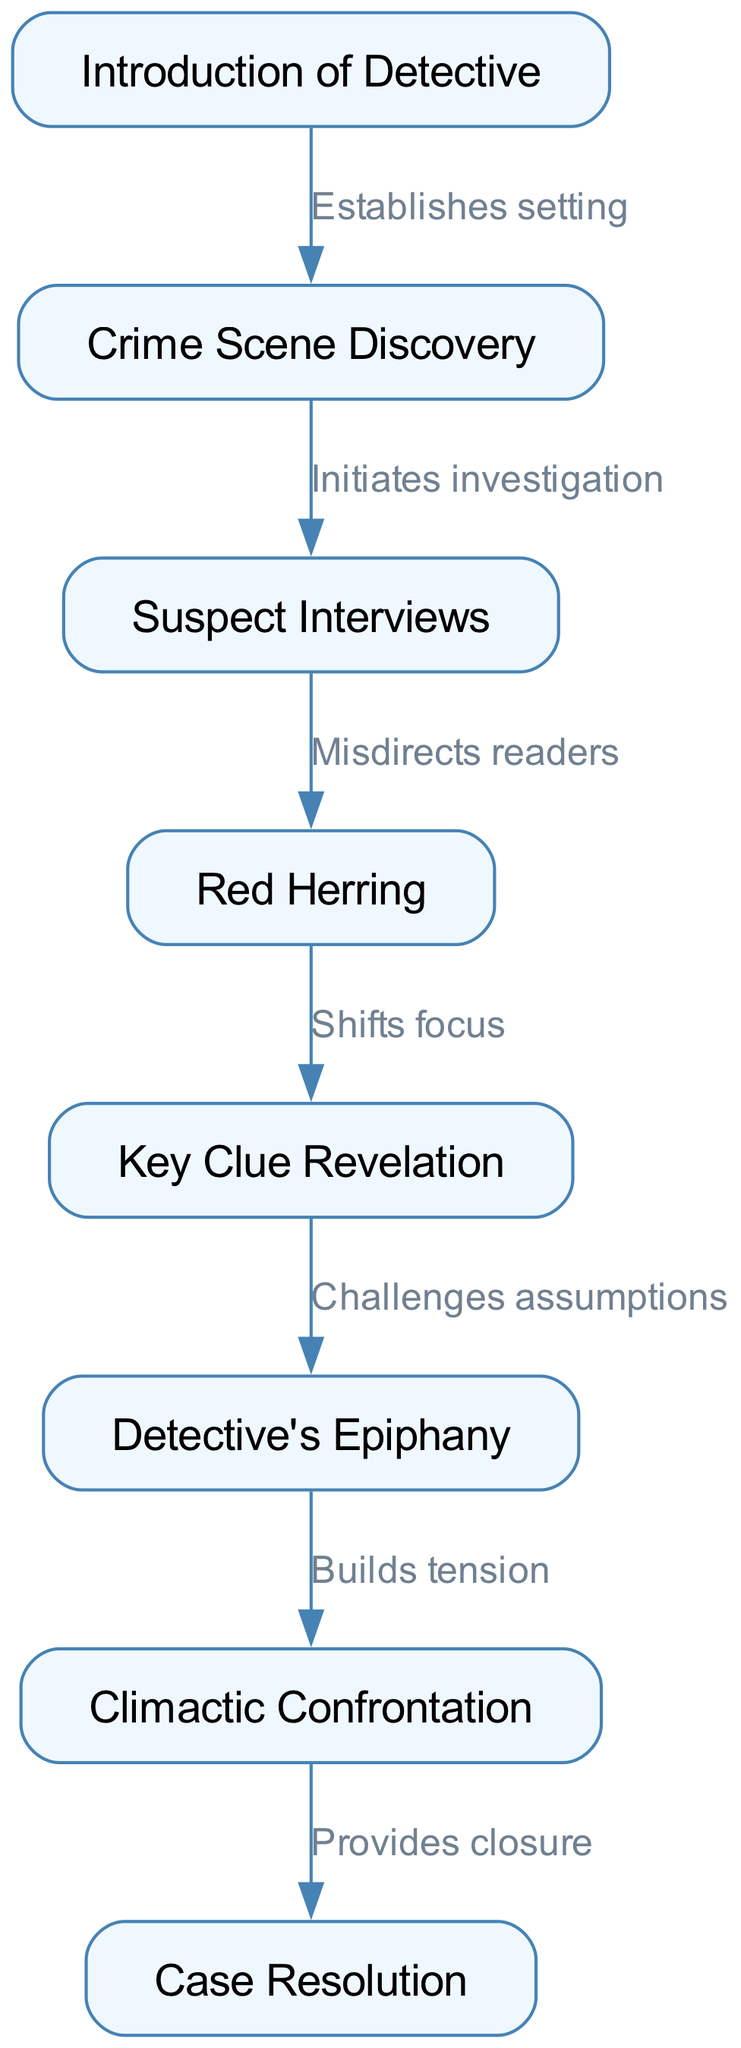What is the first node in the diagram? The first node listed in the diagram is the introduction of the detective, which sets the stage for the narrative. It can be identified as node "1."
Answer: Introduction of Detective How many nodes are present in the diagram? The diagram contains a total of eight nodes, each representing key plot points and character developments in the story arc of a classic mystery novel.
Answer: Eight What is the relationship between the "Crime Scene Discovery" and "Suspect Interviews"? The connection from "Crime Scene Discovery" to "Suspect Interviews" indicates that discovering the crime scene initiates the investigation process, leading to interviews with suspects.
Answer: Initiates investigation What does the "Red Herring" do in the story arc? The "Red Herring" serves to misdirect readers away from the true culprit, creating suspense and intrigue, as indicated by the edge leading from node "3" to node "4."
Answer: Misdirects readers How does "Key Clue Revelation" affect the progression of the investigation? The revelation of the key clue challenges previous assumptions made by the detective and shifts the focus back to important leads, demonstrating its critical role in the plot's development.
Answer: Challenges assumptions What is the final outcome in the diagram? The final outcome of the diagram is represented by "Case Resolution," signifying the conclusion of the story where all plot points are tied together. This is the ending node of the diagram.
Answer: Case Resolution Which node follows the "Detective's Epiphany"? After the "Detective's Epiphany," the next node in the sequence is "Climactic Confrontation," indicating a build-up of tension leading to a pivotal moment in the story.
Answer: Climactic Confrontation How many edges are in the diagram? There are seven edges connecting the various nodes, illustrating the relationships and flow between the different key plot points in the mystery novel.
Answer: Seven What does the edge between "Climactic Confrontation" and "Case Resolution" signify? The edge indicates that the climactic confrontation ultimately leads to the resolution of the case, providing closure to the events that have unfolded in the story.
Answer: Provides closure 